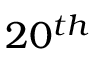Convert formula to latex. <formula><loc_0><loc_0><loc_500><loc_500>2 0 ^ { t h }</formula> 